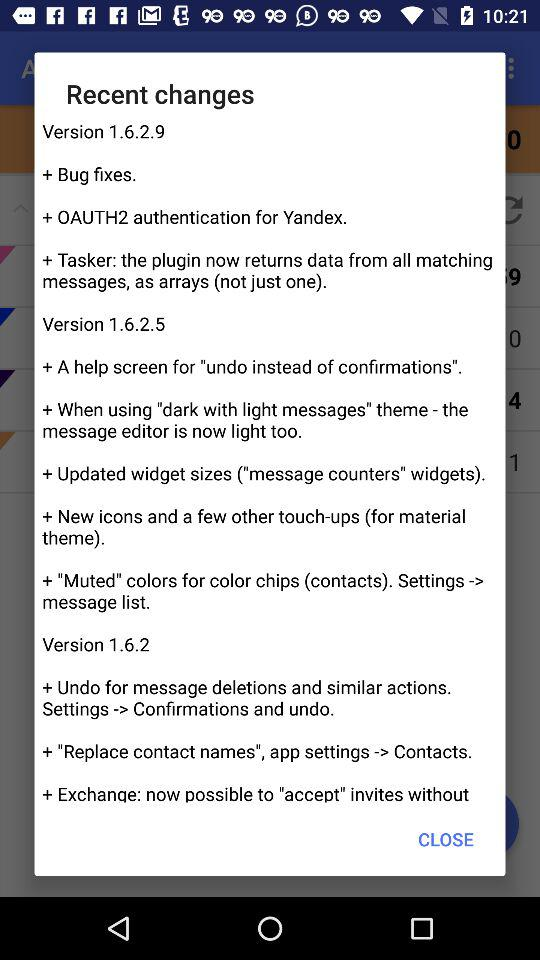What are the recent changes in version 1.6.2.9? The recent changes are "Bug fixes", "OAUTH2 authentication for Yandex" and "Tasker: the plugin now returns data from all matching messages, as arrays (not just one)". 